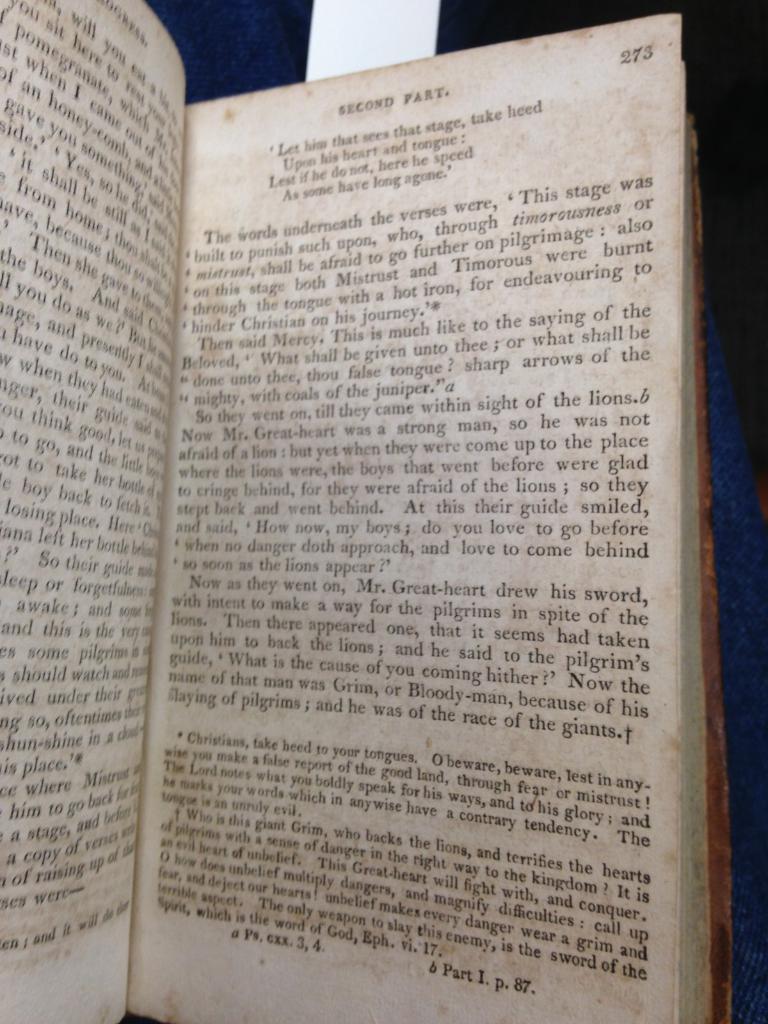What part is mentioned on the right page?
Make the answer very short. Second part. 